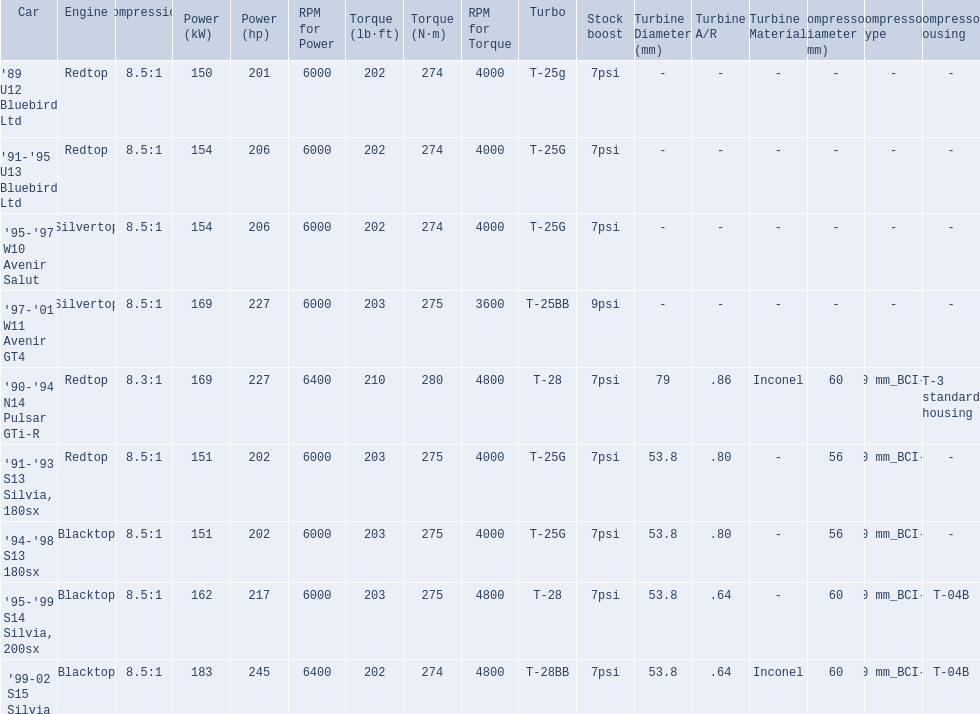What cars are there? '89 U12 Bluebird Ltd, 7psi, '91-'95 U13 Bluebird Ltd, 7psi, '95-'97 W10 Avenir Salut, 7psi, '97-'01 W11 Avenir GT4, 9psi, '90-'94 N14 Pulsar GTi-R, 7psi, '91-'93 S13 Silvia, 180sx, 7psi, '94-'98 S13 180sx, 7psi, '95-'99 S14 Silvia, 200sx, 7psi, '99-02 S15 Silvia, 7psi. Which stock boost is over 7psi? '97-'01 W11 Avenir GT4, 9psi. What car is it? '97-'01 W11 Avenir GT4. 